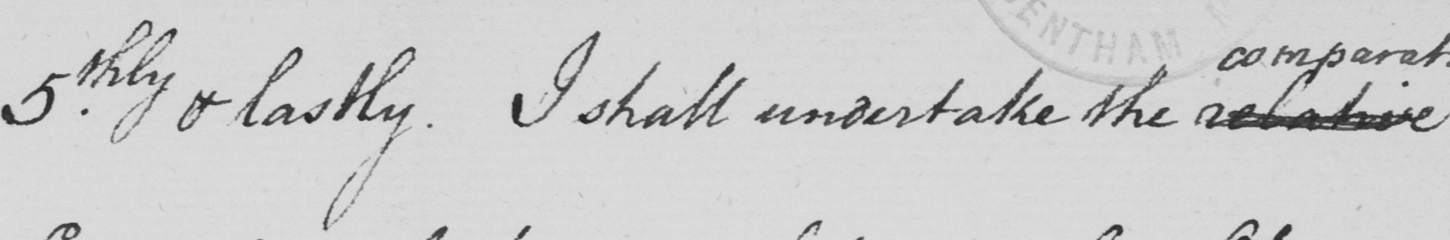What is written in this line of handwriting? 5.thly & lastly . I shall undertake the relative 